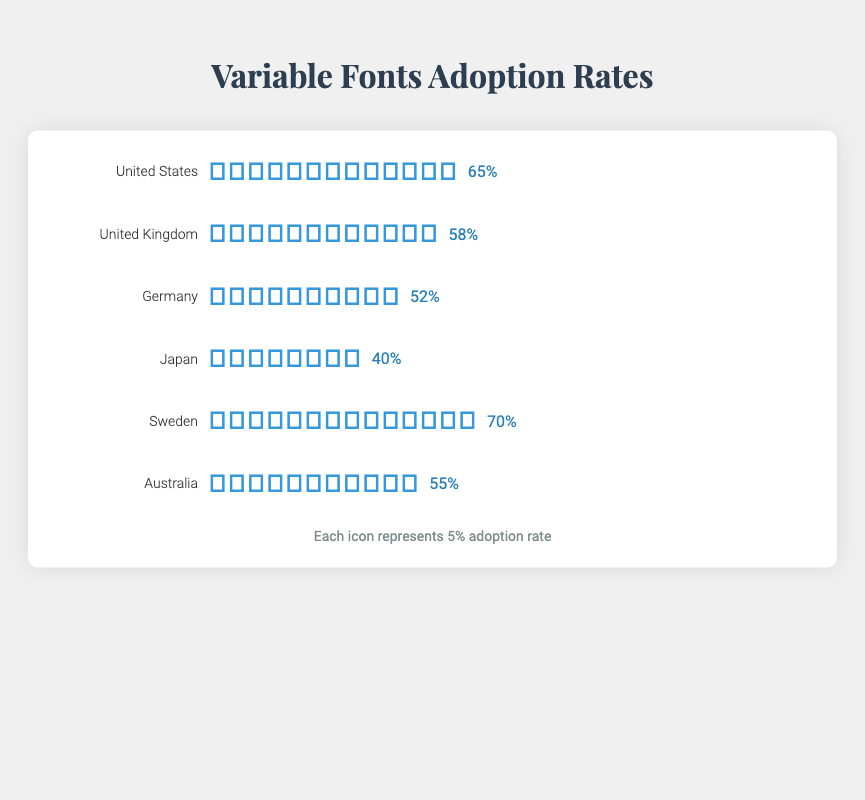What is the adoption rate of variable fonts in Sweden? Look at the adoption rate value and icon count next to Sweden in the isotype plot.
Answer: 70% Which country has the highest adoption rate of variable fonts? Compare the adoption rates shown next to each country. Sweden has 70%, which is the highest.
Answer: Sweden How many icons represent the United Kingdom's adoption rate? Count the number of icons next to the United Kingdom in the isotype plot. Each icon represents 5%. The United Kingdom has 12 icons.
Answer: 12 What is the difference in adoption rate between the United States and Japan? Find the adoption rate for the United States (65%) and Japan (40%), then subtract Japan's rate from the United States' rate.
Answer: 25% How many countries have an adoption rate greater than 50%? Look at the adoption rates for all countries and count those greater than 50%. The United States, United Kingdom, Germany, Sweden, and Australia all have adoption rates above 50%. Total is 5 countries.
Answer: 5 What is the total number of icons used in the plot? Sum the icon counts for each country: 13 (US) + 12 (UK) + 10 (Germany) + 8 (Japan) + 14 (Sweden) + 11 (Australia).
Answer: 68 Which two countries have the closest adoption rates? Compare the difference in adoption rates for each pair of countries. The United Kingdom (58%) and Australia (55%) have a difference of 3%, which is the smallest.
Answer: United Kingdom and Australia How many countries are represented in the isotype plot? Count the number of unique country names listed in the plot.
Answer: 6 What is the average adoption rate across all countries represented? Sum the adoption rates and divide by the number of countries. (65 + 58 + 52 + 40 + 70 + 55) / 6 = 340 / 6.
Answer: Around 56.7% Which country has the lowest adoption rate, and what is it? Compare the adoption rates for each country, the lowest is 40%.
Answer: Japan 